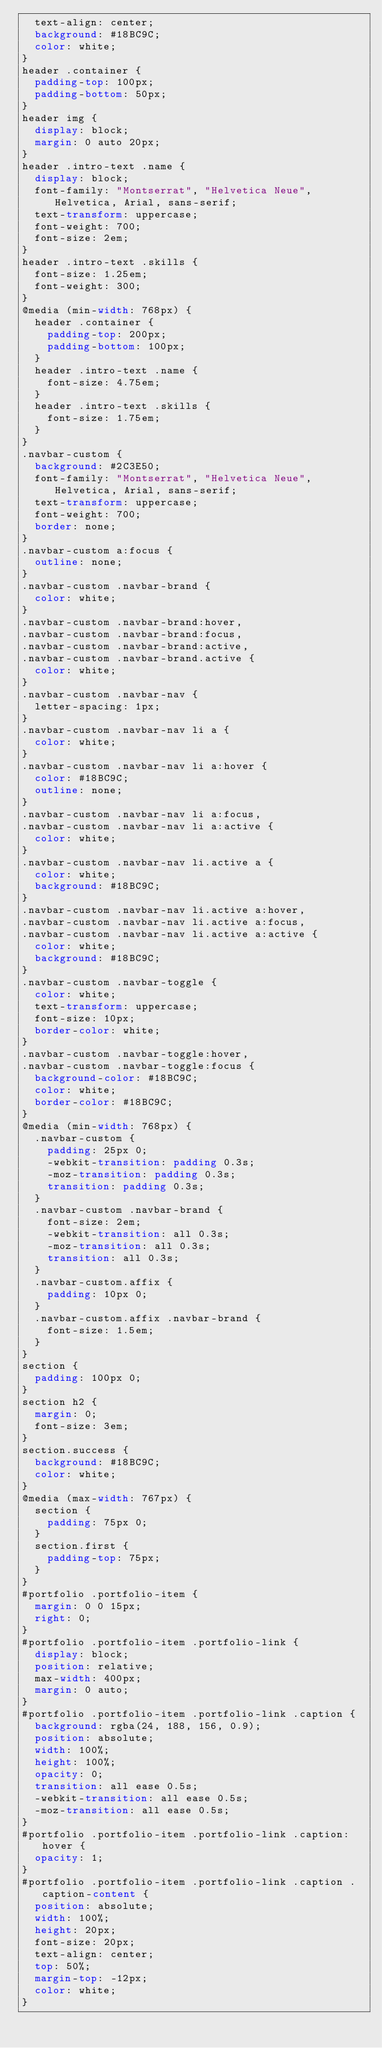Convert code to text. <code><loc_0><loc_0><loc_500><loc_500><_CSS_>  text-align: center;
  background: #18BC9C;
  color: white;
}
header .container {
  padding-top: 100px;
  padding-bottom: 50px;
}
header img {
  display: block;
  margin: 0 auto 20px;
}
header .intro-text .name {
  display: block;
  font-family: "Montserrat", "Helvetica Neue", Helvetica, Arial, sans-serif;
  text-transform: uppercase;
  font-weight: 700;
  font-size: 2em;
}
header .intro-text .skills {
  font-size: 1.25em;
  font-weight: 300;
}
@media (min-width: 768px) {
  header .container {
    padding-top: 200px;
    padding-bottom: 100px;
  }
  header .intro-text .name {
    font-size: 4.75em;
  }
  header .intro-text .skills {
    font-size: 1.75em;
  }
}
.navbar-custom {
  background: #2C3E50;
  font-family: "Montserrat", "Helvetica Neue", Helvetica, Arial, sans-serif;
  text-transform: uppercase;
  font-weight: 700;
  border: none;
}
.navbar-custom a:focus {
  outline: none;
}
.navbar-custom .navbar-brand {
  color: white;
}
.navbar-custom .navbar-brand:hover,
.navbar-custom .navbar-brand:focus,
.navbar-custom .navbar-brand:active,
.navbar-custom .navbar-brand.active {
  color: white;
}
.navbar-custom .navbar-nav {
  letter-spacing: 1px;
}
.navbar-custom .navbar-nav li a {
  color: white;
}
.navbar-custom .navbar-nav li a:hover {
  color: #18BC9C;
  outline: none;
}
.navbar-custom .navbar-nav li a:focus,
.navbar-custom .navbar-nav li a:active {
  color: white;
}
.navbar-custom .navbar-nav li.active a {
  color: white;
  background: #18BC9C;
}
.navbar-custom .navbar-nav li.active a:hover,
.navbar-custom .navbar-nav li.active a:focus,
.navbar-custom .navbar-nav li.active a:active {
  color: white;
  background: #18BC9C;
}
.navbar-custom .navbar-toggle {
  color: white;
  text-transform: uppercase;
  font-size: 10px;
  border-color: white;
}
.navbar-custom .navbar-toggle:hover,
.navbar-custom .navbar-toggle:focus {
  background-color: #18BC9C;
  color: white;
  border-color: #18BC9C;
}
@media (min-width: 768px) {
  .navbar-custom {
    padding: 25px 0;
    -webkit-transition: padding 0.3s;
    -moz-transition: padding 0.3s;
    transition: padding 0.3s;
  }
  .navbar-custom .navbar-brand {
    font-size: 2em;
    -webkit-transition: all 0.3s;
    -moz-transition: all 0.3s;
    transition: all 0.3s;
  }
  .navbar-custom.affix {
    padding: 10px 0;
  }
  .navbar-custom.affix .navbar-brand {
    font-size: 1.5em;
  }
}
section {
  padding: 100px 0;
}
section h2 {
  margin: 0;
  font-size: 3em;
}
section.success {
  background: #18BC9C;
  color: white;
}
@media (max-width: 767px) {
  section {
    padding: 75px 0;
  }
  section.first {
    padding-top: 75px;
  }
}
#portfolio .portfolio-item {
  margin: 0 0 15px;
  right: 0;
}
#portfolio .portfolio-item .portfolio-link {
  display: block;
  position: relative;
  max-width: 400px;
  margin: 0 auto;
}
#portfolio .portfolio-item .portfolio-link .caption {
  background: rgba(24, 188, 156, 0.9);
  position: absolute;
  width: 100%;
  height: 100%;
  opacity: 0;
  transition: all ease 0.5s;
  -webkit-transition: all ease 0.5s;
  -moz-transition: all ease 0.5s;
}
#portfolio .portfolio-item .portfolio-link .caption:hover {
  opacity: 1;
}
#portfolio .portfolio-item .portfolio-link .caption .caption-content {
  position: absolute;
  width: 100%;
  height: 20px;
  font-size: 20px;
  text-align: center;
  top: 50%;
  margin-top: -12px;
  color: white;
}</code> 